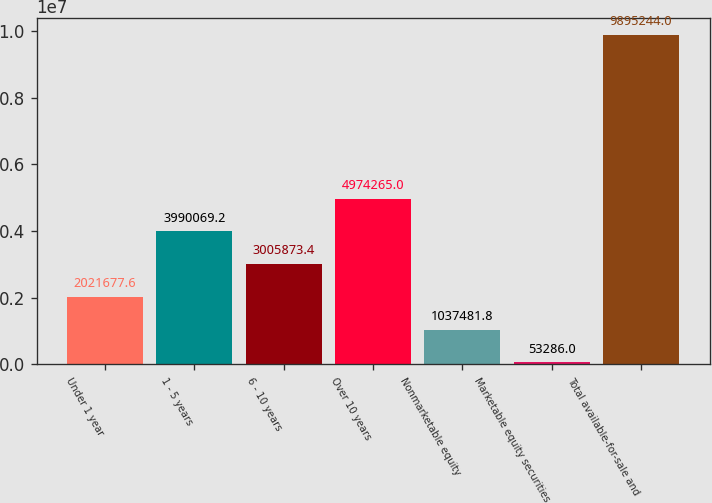Convert chart. <chart><loc_0><loc_0><loc_500><loc_500><bar_chart><fcel>Under 1 year<fcel>1 - 5 years<fcel>6 - 10 years<fcel>Over 10 years<fcel>Nonmarketable equity<fcel>Marketable equity securities<fcel>Total available-for-sale and<nl><fcel>2.02168e+06<fcel>3.99007e+06<fcel>3.00587e+06<fcel>4.97426e+06<fcel>1.03748e+06<fcel>53286<fcel>9.89524e+06<nl></chart> 